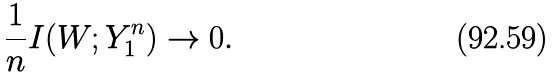<formula> <loc_0><loc_0><loc_500><loc_500>\frac { 1 } { n } I ( W ; Y _ { 1 } ^ { n } ) \rightarrow 0 .</formula> 